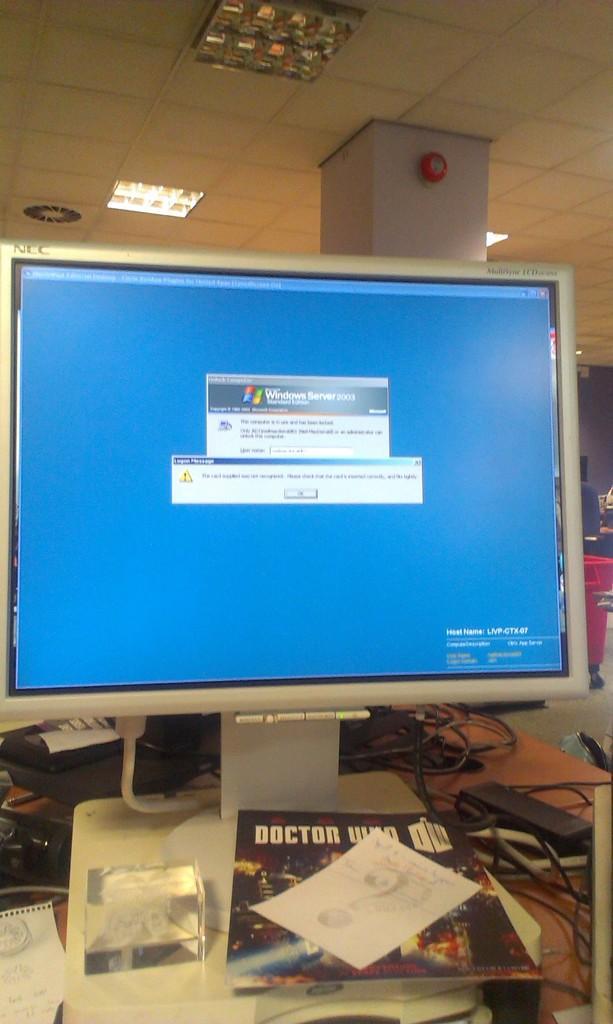Can you describe this image briefly? In this image there is a monitor on the table. There is a book on the monitor. There are few objects on the table. Right side there are few objects. Behind the monitor there is a pillar. Top of the image there are few lights attached to the roof. 